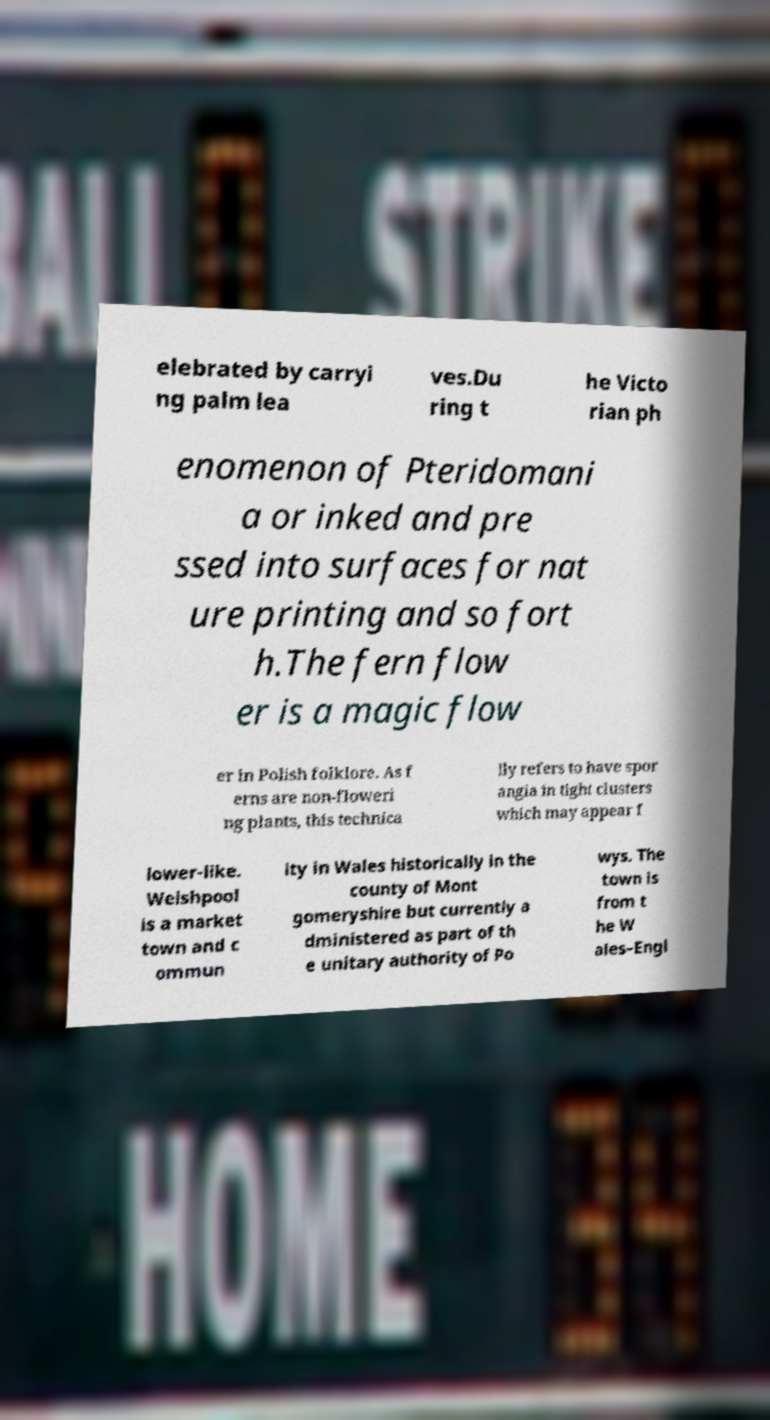Please read and relay the text visible in this image. What does it say? elebrated by carryi ng palm lea ves.Du ring t he Victo rian ph enomenon of Pteridomani a or inked and pre ssed into surfaces for nat ure printing and so fort h.The fern flow er is a magic flow er in Polish folklore. As f erns are non-floweri ng plants, this technica lly refers to have spor angia in tight clusters which may appear f lower-like. Welshpool is a market town and c ommun ity in Wales historically in the county of Mont gomeryshire but currently a dministered as part of th e unitary authority of Po wys. The town is from t he W ales–Engl 